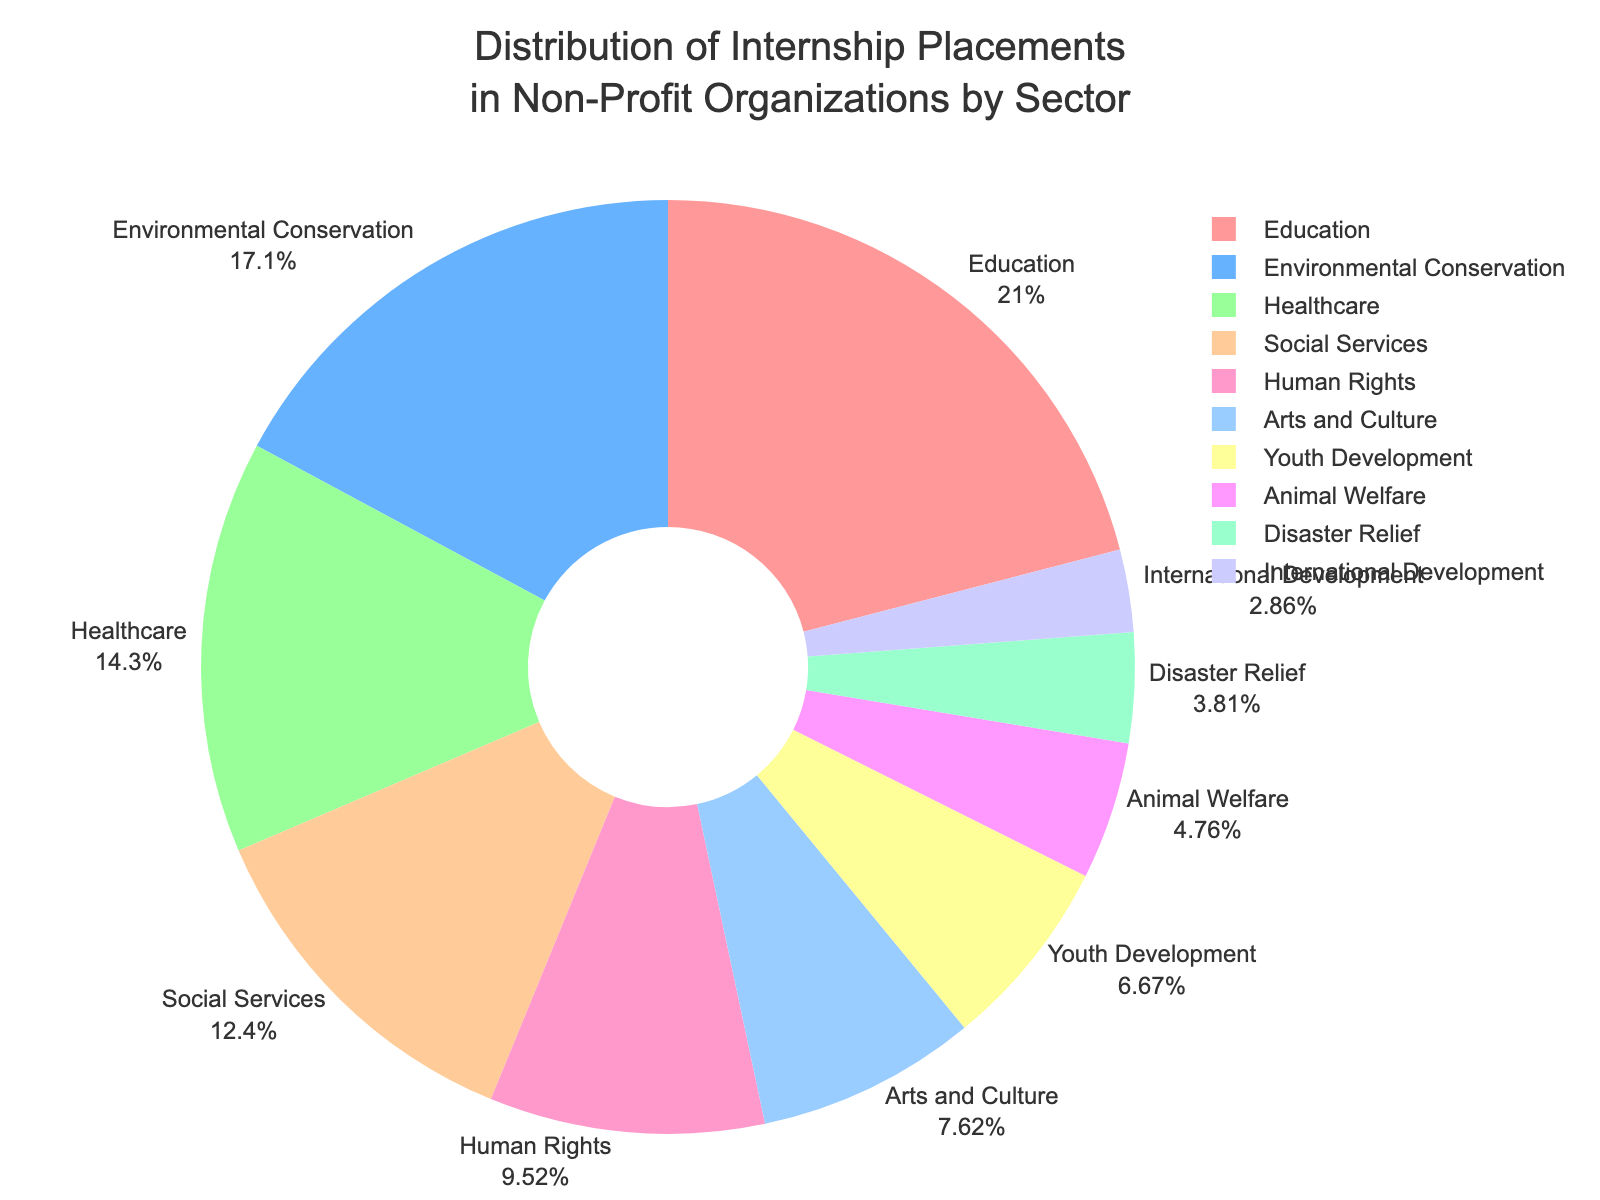Which sector has the largest proportion of internship placements? The Education sector has the largest proportion of internship placements at 22%. We can identify this by observing the highest percentage slice in the pie chart.
Answer: Education How many sectors have a proportion of 10% or higher? By examining the pie chart, we can count the sectors with slices showing 10% or higher: Education (22%), Environmental Conservation (18%), Healthcare (15%), Social Services (13%), and Human Rights (10%). There are 5 such sectors.
Answer: 5 Is the proportion of internship placements in Healthcare greater than that in Arts and Culture? Yes, Healthcare has a higher proportion (15%) than Arts and Culture (8%). We can verify this by comparing the sizes of the respective slices in the pie chart.
Answer: Yes What is the total percentage of internship placements for sectors with less than 10%? Adding the percentages of sectors with less than 10%: Arts and Culture (8%) + Youth Development (7%) + Animal Welfare (5%) + Disaster Relief (4%) + International Development (3%) = 27%.
Answer: 27% Which sectors have the same color in the pie chart? Each sector in the pie chart has a unique color. The visual attributes of the chart show that no two sectors share the same color, ensuring distinct visual representation for each.
Answer: None What is the difference in percentage between the largest and the smallest sector? The largest sector is Education with 22%, and the smallest is International Development with 3%. The difference is calculated as 22% - 3% = 19%.
Answer: 19% Arrange the sectors in descending order of their internship placement percentages. The sectors arranged from the highest to the lowest percentage are: Education (22%), Environmental Conservation (18%), Healthcare (15%), Social Services (13%), Human Rights (10%), Arts and Culture (8%), Youth Development (7%), Animal Welfare (5%), Disaster Relief (4%), International Development (3%).
Answer: Education, Environmental Conservation, Healthcare, Social Services, Human Rights, Arts and Culture, Youth Development, Animal Welfare, Disaster Relief, International Development What proportion of internship placements are in sectors related to health and human services (Healthcare and Social Services combined)? Adding the percentages for Healthcare (15%) and Social Services (13%), we find that the combined proportion for health and human services sectors is 15% + 13% = 28%.
Answer: 28% If a new sector 'Community Development' were to be introduced, how much percentage should be reallocated equally from all sectors to give it an equal share without changing the total of 100%? To introduce a new sector with an equal share, we need to reduce each current sector's share. Since there are 10 sectors, each would contribute 1/11 of its current proportion to the new sector. For example, for Education (22%), the reduced proportion is (22%) * (10/11). The new share for each sector would sum to 90.91%, and Community Development would get 9.09%.
Answer: 9.09% from each 